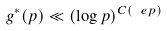Convert formula to latex. <formula><loc_0><loc_0><loc_500><loc_500>g ^ { * } ( p ) \ll ( \log p ) ^ { C ( \ e p ) }</formula> 